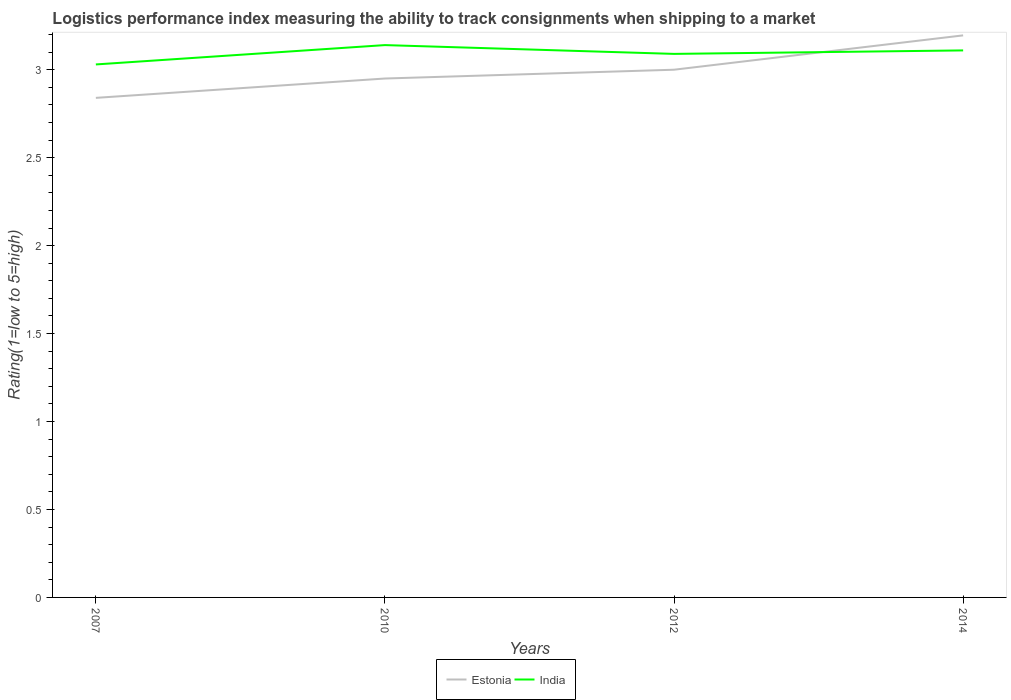Does the line corresponding to Estonia intersect with the line corresponding to India?
Your answer should be very brief. Yes. Is the number of lines equal to the number of legend labels?
Provide a succinct answer. Yes. Across all years, what is the maximum Logistic performance index in Estonia?
Make the answer very short. 2.84. In which year was the Logistic performance index in India maximum?
Offer a very short reply. 2007. What is the total Logistic performance index in India in the graph?
Ensure brevity in your answer.  -0.02. What is the difference between the highest and the second highest Logistic performance index in India?
Ensure brevity in your answer.  0.11. What is the difference between the highest and the lowest Logistic performance index in Estonia?
Your answer should be very brief. 2. Is the Logistic performance index in India strictly greater than the Logistic performance index in Estonia over the years?
Your response must be concise. No. Does the graph contain any zero values?
Your response must be concise. No. Does the graph contain grids?
Keep it short and to the point. No. What is the title of the graph?
Your answer should be very brief. Logistics performance index measuring the ability to track consignments when shipping to a market. Does "Georgia" appear as one of the legend labels in the graph?
Keep it short and to the point. No. What is the label or title of the Y-axis?
Provide a short and direct response. Rating(1=low to 5=high). What is the Rating(1=low to 5=high) of Estonia in 2007?
Ensure brevity in your answer.  2.84. What is the Rating(1=low to 5=high) in India in 2007?
Your response must be concise. 3.03. What is the Rating(1=low to 5=high) of Estonia in 2010?
Give a very brief answer. 2.95. What is the Rating(1=low to 5=high) of India in 2010?
Provide a succinct answer. 3.14. What is the Rating(1=low to 5=high) in Estonia in 2012?
Offer a very short reply. 3. What is the Rating(1=low to 5=high) of India in 2012?
Make the answer very short. 3.09. What is the Rating(1=low to 5=high) in Estonia in 2014?
Offer a terse response. 3.2. What is the Rating(1=low to 5=high) of India in 2014?
Give a very brief answer. 3.11. Across all years, what is the maximum Rating(1=low to 5=high) in Estonia?
Offer a very short reply. 3.2. Across all years, what is the maximum Rating(1=low to 5=high) in India?
Offer a very short reply. 3.14. Across all years, what is the minimum Rating(1=low to 5=high) in Estonia?
Give a very brief answer. 2.84. Across all years, what is the minimum Rating(1=low to 5=high) of India?
Provide a succinct answer. 3.03. What is the total Rating(1=low to 5=high) of Estonia in the graph?
Keep it short and to the point. 11.99. What is the total Rating(1=low to 5=high) of India in the graph?
Provide a succinct answer. 12.37. What is the difference between the Rating(1=low to 5=high) of Estonia in 2007 and that in 2010?
Make the answer very short. -0.11. What is the difference between the Rating(1=low to 5=high) in India in 2007 and that in 2010?
Offer a very short reply. -0.11. What is the difference between the Rating(1=low to 5=high) in Estonia in 2007 and that in 2012?
Your answer should be very brief. -0.16. What is the difference between the Rating(1=low to 5=high) of India in 2007 and that in 2012?
Make the answer very short. -0.06. What is the difference between the Rating(1=low to 5=high) in Estonia in 2007 and that in 2014?
Provide a succinct answer. -0.36. What is the difference between the Rating(1=low to 5=high) in India in 2007 and that in 2014?
Provide a short and direct response. -0.08. What is the difference between the Rating(1=low to 5=high) in Estonia in 2010 and that in 2012?
Ensure brevity in your answer.  -0.05. What is the difference between the Rating(1=low to 5=high) of Estonia in 2010 and that in 2014?
Keep it short and to the point. -0.25. What is the difference between the Rating(1=low to 5=high) in India in 2010 and that in 2014?
Provide a short and direct response. 0.03. What is the difference between the Rating(1=low to 5=high) of Estonia in 2012 and that in 2014?
Your answer should be very brief. -0.2. What is the difference between the Rating(1=low to 5=high) of India in 2012 and that in 2014?
Your answer should be compact. -0.02. What is the difference between the Rating(1=low to 5=high) of Estonia in 2007 and the Rating(1=low to 5=high) of India in 2010?
Make the answer very short. -0.3. What is the difference between the Rating(1=low to 5=high) of Estonia in 2007 and the Rating(1=low to 5=high) of India in 2014?
Make the answer very short. -0.27. What is the difference between the Rating(1=low to 5=high) in Estonia in 2010 and the Rating(1=low to 5=high) in India in 2012?
Your response must be concise. -0.14. What is the difference between the Rating(1=low to 5=high) of Estonia in 2010 and the Rating(1=low to 5=high) of India in 2014?
Provide a short and direct response. -0.16. What is the difference between the Rating(1=low to 5=high) in Estonia in 2012 and the Rating(1=low to 5=high) in India in 2014?
Offer a very short reply. -0.11. What is the average Rating(1=low to 5=high) of Estonia per year?
Provide a short and direct response. 3. What is the average Rating(1=low to 5=high) in India per year?
Your answer should be compact. 3.09. In the year 2007, what is the difference between the Rating(1=low to 5=high) of Estonia and Rating(1=low to 5=high) of India?
Provide a short and direct response. -0.19. In the year 2010, what is the difference between the Rating(1=low to 5=high) of Estonia and Rating(1=low to 5=high) of India?
Keep it short and to the point. -0.19. In the year 2012, what is the difference between the Rating(1=low to 5=high) of Estonia and Rating(1=low to 5=high) of India?
Your response must be concise. -0.09. In the year 2014, what is the difference between the Rating(1=low to 5=high) of Estonia and Rating(1=low to 5=high) of India?
Give a very brief answer. 0.09. What is the ratio of the Rating(1=low to 5=high) of Estonia in 2007 to that in 2010?
Offer a terse response. 0.96. What is the ratio of the Rating(1=low to 5=high) in Estonia in 2007 to that in 2012?
Provide a succinct answer. 0.95. What is the ratio of the Rating(1=low to 5=high) of India in 2007 to that in 2012?
Make the answer very short. 0.98. What is the ratio of the Rating(1=low to 5=high) of Estonia in 2007 to that in 2014?
Provide a succinct answer. 0.89. What is the ratio of the Rating(1=low to 5=high) in India in 2007 to that in 2014?
Provide a short and direct response. 0.97. What is the ratio of the Rating(1=low to 5=high) in Estonia in 2010 to that in 2012?
Provide a short and direct response. 0.98. What is the ratio of the Rating(1=low to 5=high) in India in 2010 to that in 2012?
Keep it short and to the point. 1.02. What is the ratio of the Rating(1=low to 5=high) in Estonia in 2010 to that in 2014?
Keep it short and to the point. 0.92. What is the ratio of the Rating(1=low to 5=high) of India in 2010 to that in 2014?
Your answer should be very brief. 1.01. What is the ratio of the Rating(1=low to 5=high) of Estonia in 2012 to that in 2014?
Provide a succinct answer. 0.94. What is the difference between the highest and the second highest Rating(1=low to 5=high) in Estonia?
Keep it short and to the point. 0.2. What is the difference between the highest and the second highest Rating(1=low to 5=high) in India?
Your answer should be very brief. 0.03. What is the difference between the highest and the lowest Rating(1=low to 5=high) in Estonia?
Offer a very short reply. 0.36. What is the difference between the highest and the lowest Rating(1=low to 5=high) in India?
Provide a succinct answer. 0.11. 